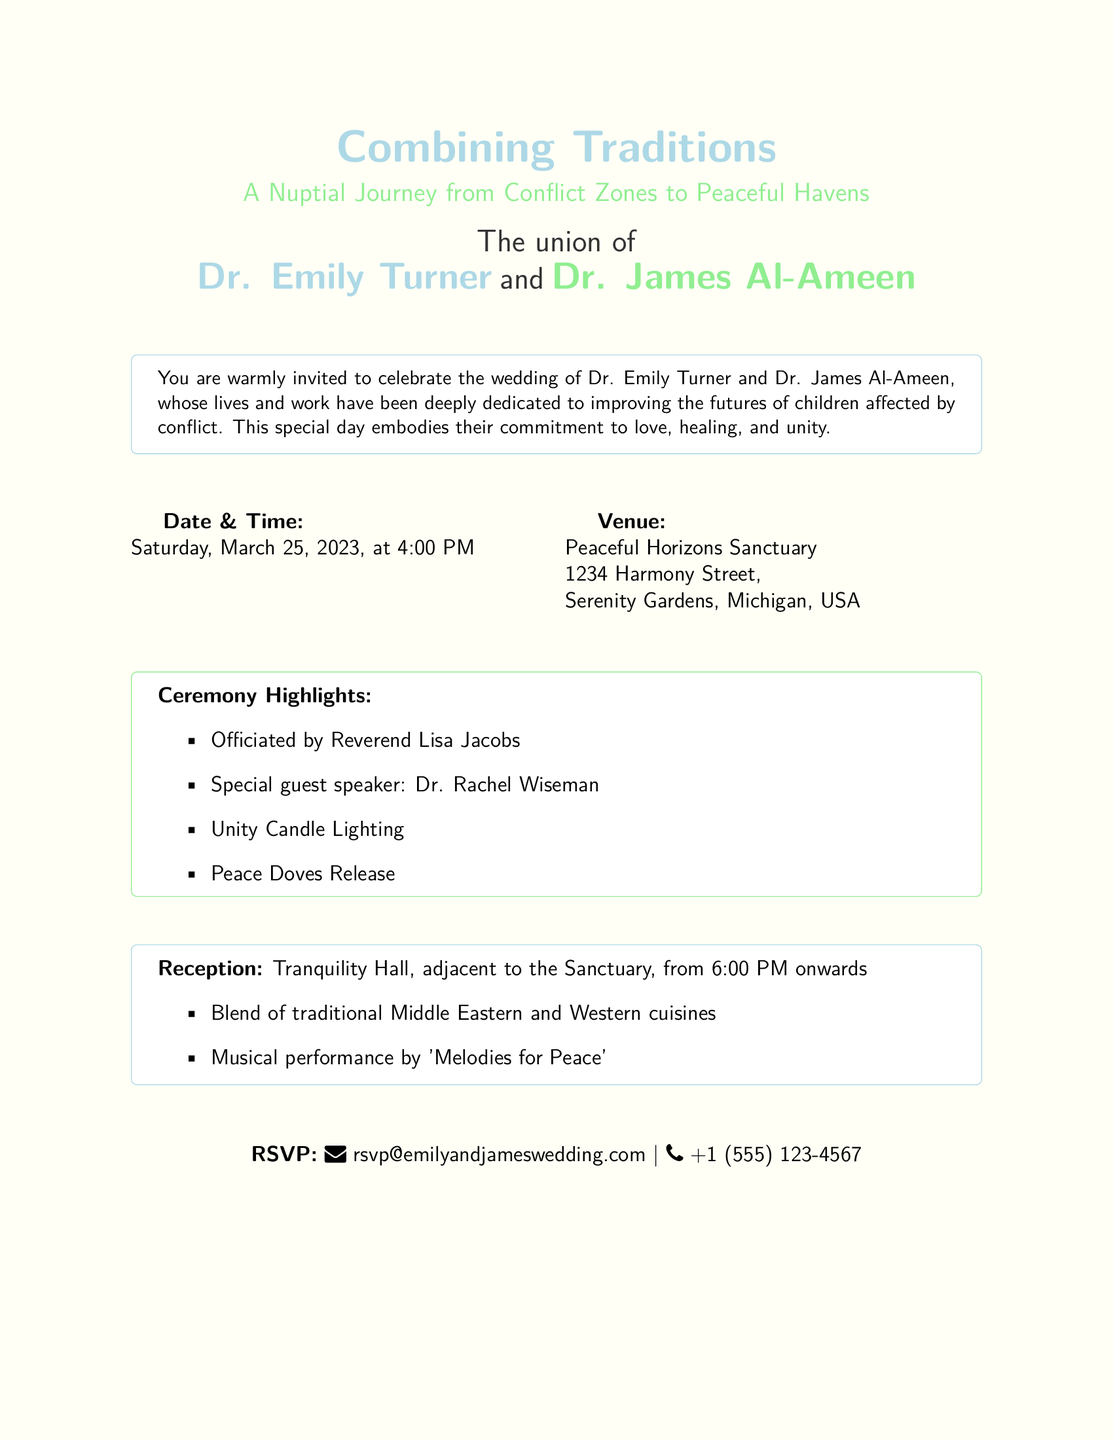What are the names of the couple? The names of the couple are listed prominently in the invitation as Dr. Emily Turner and Dr. James Al-Ameen.
Answer: Dr. Emily Turner and Dr. James Al-Ameen When is the wedding date? The wedding date is specified under the Date & Time section of the invitation.
Answer: Saturday, March 25, 2023 Where is the venue located? The venue details are provided, including the name and address of the location where the ceremony will take place.
Answer: Peaceful Horizons Sanctuary, 1234 Harmony Street, Serenity Gardens, Michigan, USA Who is officiating the ceremony? The officiant's name is mentioned in the Ceremony Highlights section of the invitation.
Answer: Reverend Lisa Jacobs What type of cuisine will be served at the reception? The document describes the cuisine at the reception, highlighting the cultural blend chosen for the event.
Answer: Traditional Middle Eastern and Western cuisines What is the dress code? The invitation includes details regarding the attire expected from guests, which is stated in the Special Notes section.
Answer: Semi-formal, soft pastel colors encouraged What special activity will occur during the ceremony? The document lists unique elements planned for the ceremony, highlighting a significant symbolic gesture.
Answer: Unity Candle Lighting What is requested instead of gifts? The invitation specifies an alternative to traditional wedding gifts in the Special Notes section.
Answer: Donations to War Child UK or the International Rescue Committee (IRC) 